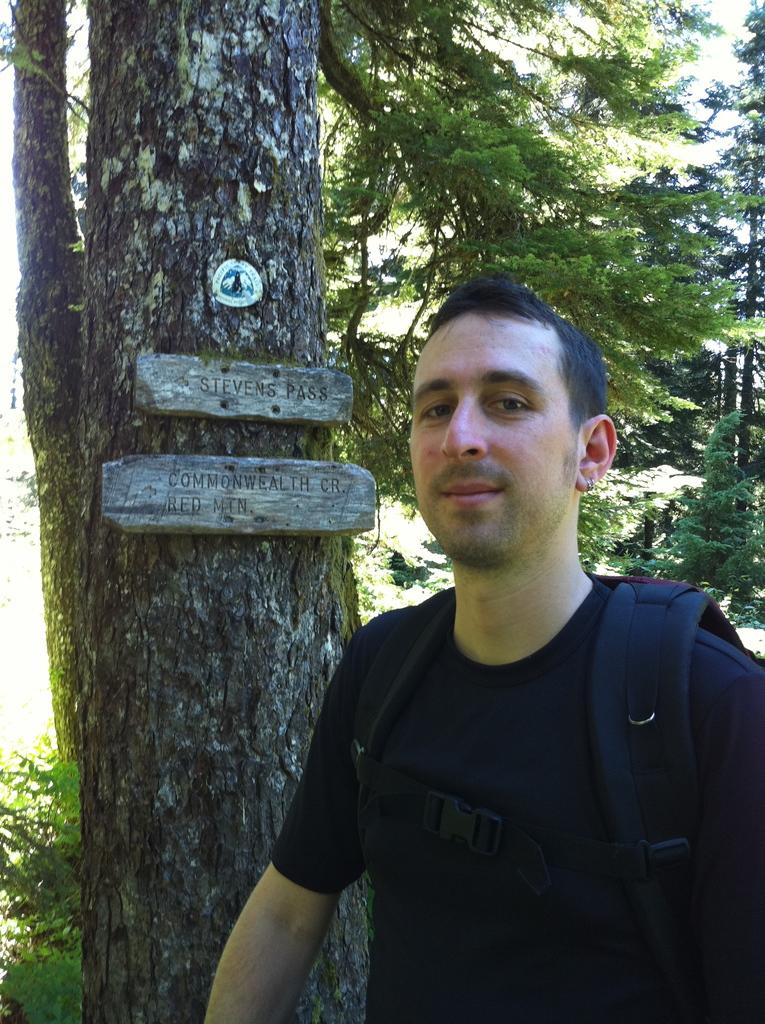Who is the main subject in the image? There is a man in the image. What is the man's position in relation to the tree? The man is standing in front of a tree. Is the man looking at something or someone in the image? Yes, the man is looking at someone. What type of body of water can be seen near the man in the image? There is no body of water present in the image; it features a man standing in front of a tree. What color is the yarn that the man is holding in the image? The man is not holding any yarn in the image. 